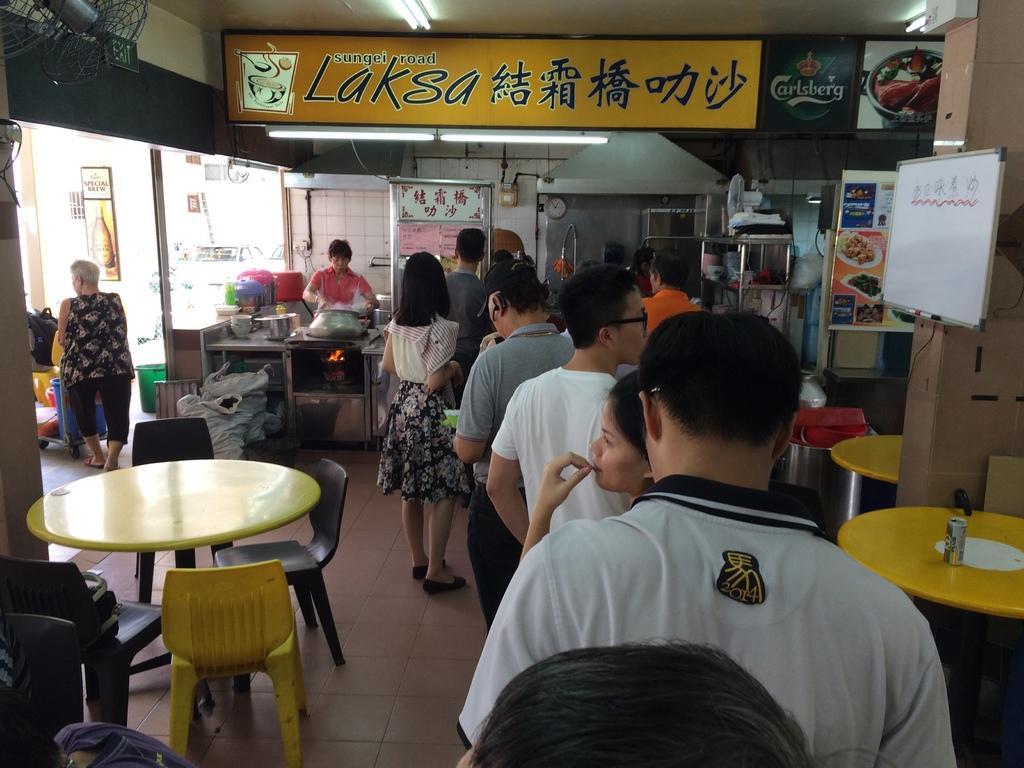Could you give a brief overview of what you see in this image? In this picture we can see a group of people they are standing and in front of them we have table, chairs and on table we can see tin, bags and in background we can see wall, rods, racks, banner, fan, windows, tub, bags, vessels. 